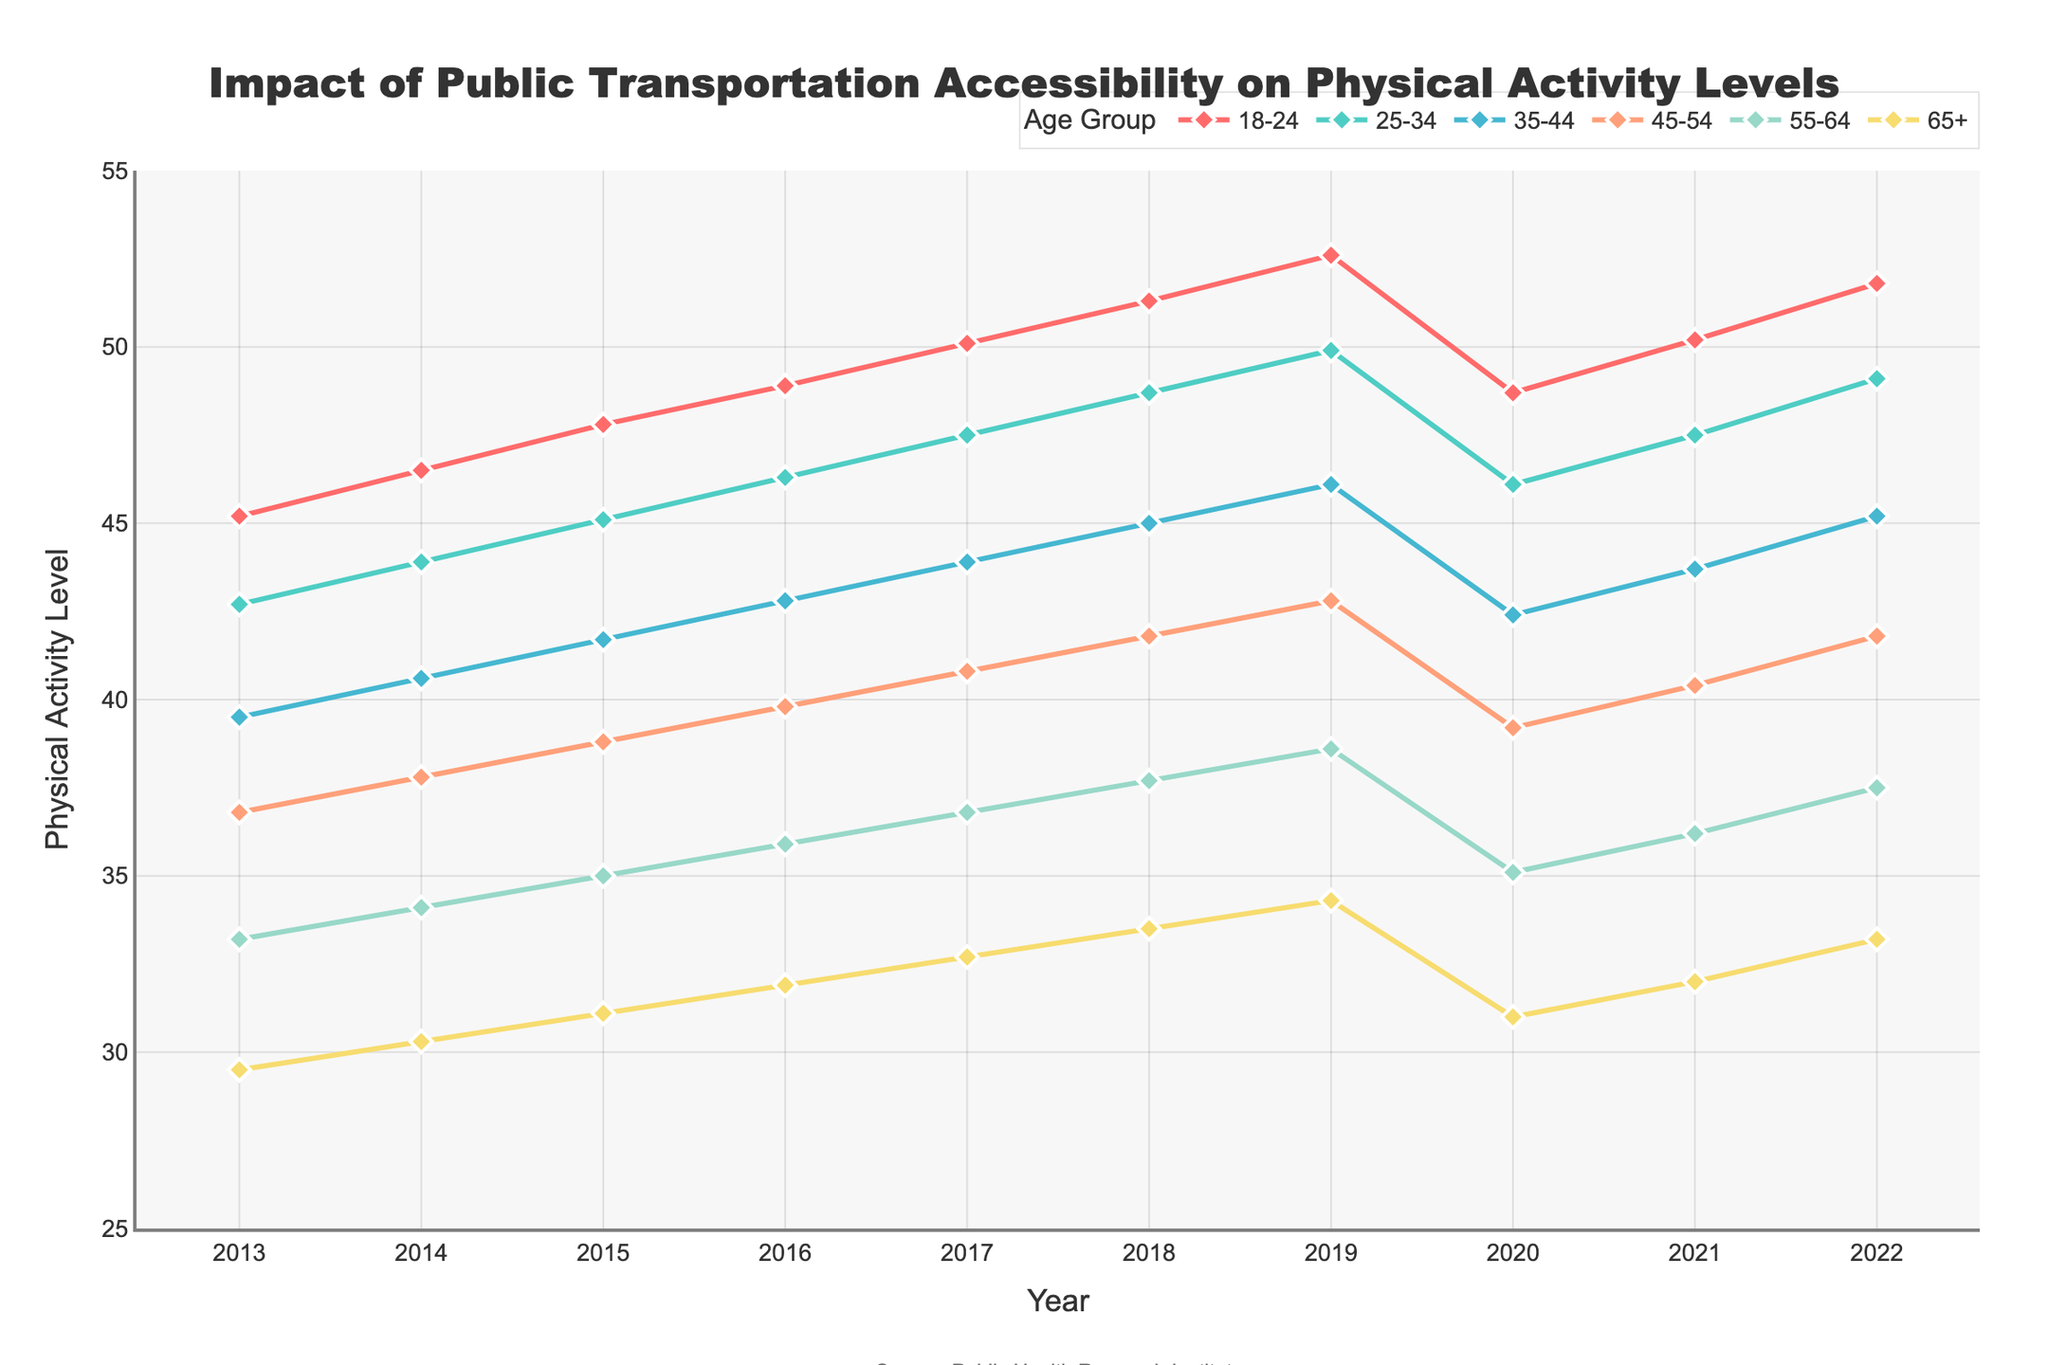What is the trend of physical activity levels in the 18-24 age group from 2013 to 2022? The trend for the 18-24 age group is generally upward from 2013 (45.2) to 2022 (51.8), with a slight dip in 2020 (48.7).
Answer: Generally upward Which age group had the highest physical activity level in 2022? In 2022, the 18-24 age group had the highest physical activity level at 51.8.
Answer: 18-24 What was the difference in physical activity levels between the 25-34 and 65+ age groups in 2016? In 2016, the 25-34 age group had a physical activity level of 46.3, and the 65+ age group had a level of 31.9. The difference is 46.3 - 31.9 = 14.4.
Answer: 14.4 How did the physical activity level for the 55-64 age group change from 2019 to 2020? The physical activity level for the 55-64 age group decreased from 38.6 in 2019 to 35.1 in 2020.
Answer: Decreased By how much did the physical activity level for the 45-54 age group increase from 2013 to 2022? In 2013, the 45-54 age group had a physical activity level of 36.8, and it increased to 41.8 in 2022. The increase is 41.8 - 36.8 = 5.0.
Answer: 5.0 Which age group shows the most consistent upward trend in physical activity levels over the decade? The 18-24 age group shows the most consistent upward trend with a steady increase from 45.2 in 2013 to 51.8 in 2022, despite a slight dip in 2020.
Answer: 18-24 What is the average physical activity level for the 35-44 age group over the decade? Add the physical activity levels for each year: 39.5 + 40.6 + 41.7 + 42.8 + 43.9 + 45.0 + 46.1 + 42.4 + 43.7 + 45.2 = 431.9. Divide by the number of years (10). 431.9 / 10 = 43.19
Answer: 43.19 